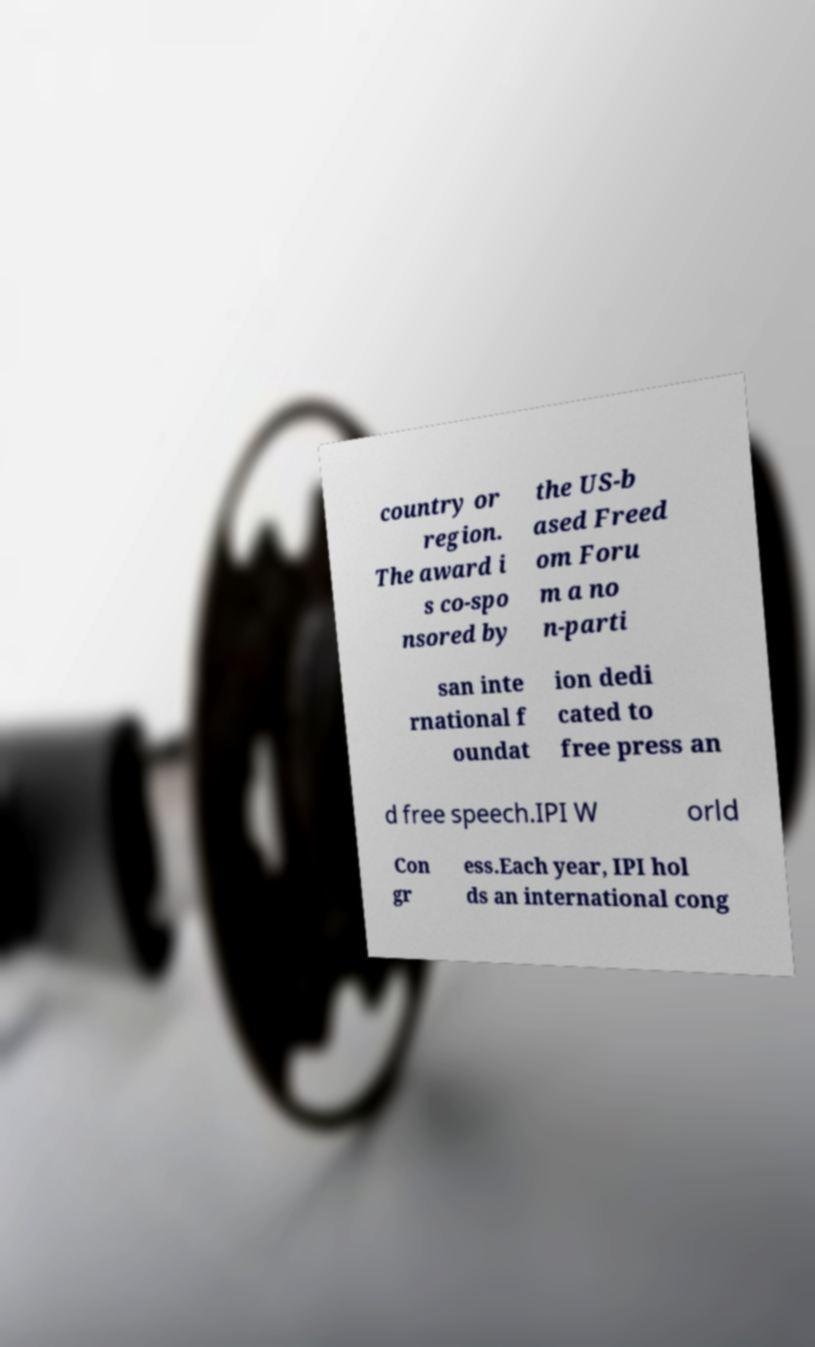Can you read and provide the text displayed in the image?This photo seems to have some interesting text. Can you extract and type it out for me? country or region. The award i s co-spo nsored by the US-b ased Freed om Foru m a no n-parti san inte rnational f oundat ion dedi cated to free press an d free speech.IPI W orld Con gr ess.Each year, IPI hol ds an international cong 